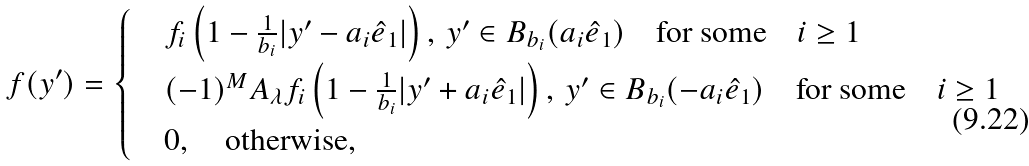<formula> <loc_0><loc_0><loc_500><loc_500>f ( y ^ { \prime } ) = \begin{cases} & f _ { i } \left ( 1 - \frac { 1 } { b _ { i } } | y ^ { \prime } - a _ { i } \hat { e } _ { 1 } | \right ) , \, y ^ { \prime } \in B _ { b _ { i } } ( a _ { i } \hat { e } _ { 1 } ) \quad \text {for some} \quad i \geq 1 \\ & ( - 1 ) ^ { M } A _ { \lambda } f _ { i } \left ( 1 - \frac { 1 } { b _ { i } } | y ^ { \prime } + a _ { i } \hat { e } _ { 1 } | \right ) , \, y ^ { \prime } \in B _ { b _ { i } } ( - a _ { i } \hat { e } _ { 1 } ) \quad \text {for some} \quad i \geq 1 \\ & 0 , \quad \text {otherwise} , \end{cases}</formula> 